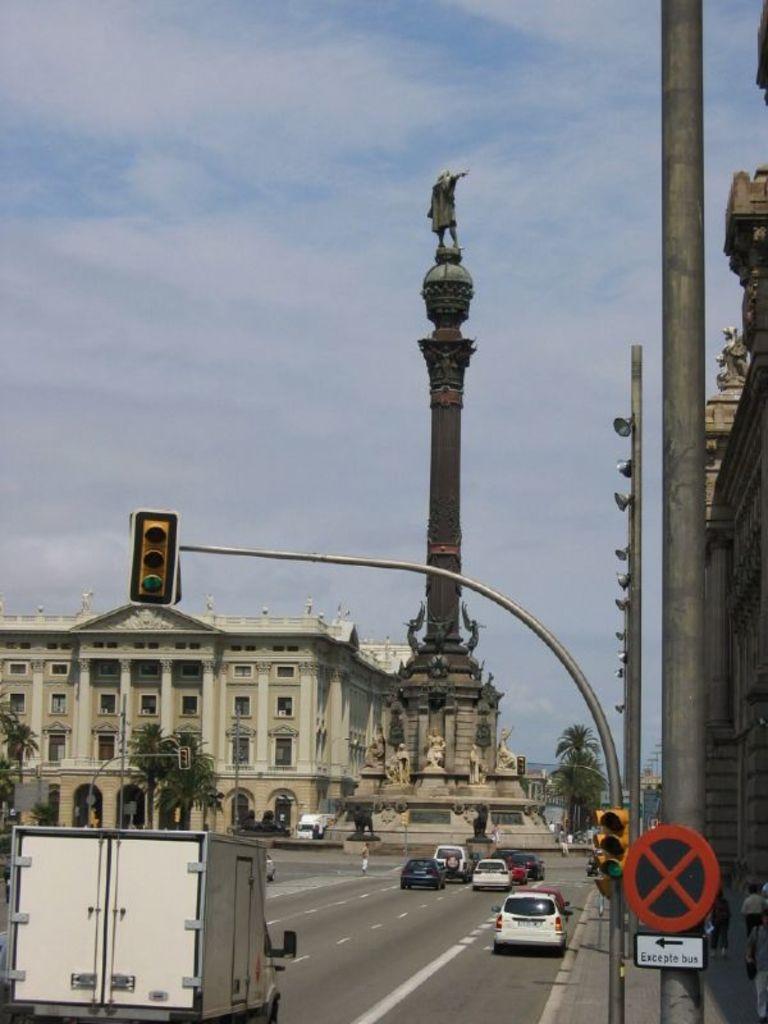Please provide a concise description of this image. In this image there are vehicles passing on the road. On the right side of the image there is a sign board. There are traffic lights. There is a lamp post. In the center of the image there is a statue. In the background of the image there are trees, buildings and sky. 